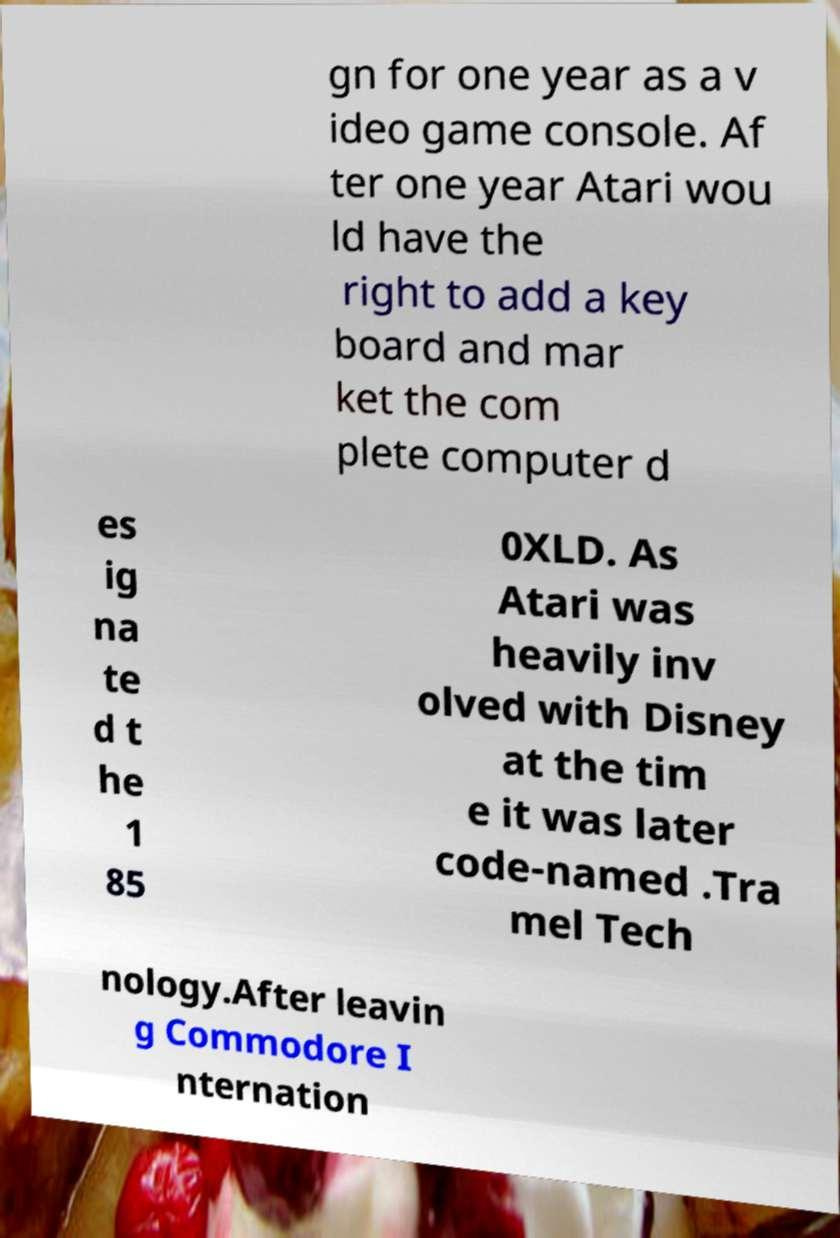Can you read and provide the text displayed in the image?This photo seems to have some interesting text. Can you extract and type it out for me? gn for one year as a v ideo game console. Af ter one year Atari wou ld have the right to add a key board and mar ket the com plete computer d es ig na te d t he 1 85 0XLD. As Atari was heavily inv olved with Disney at the tim e it was later code-named .Tra mel Tech nology.After leavin g Commodore I nternation 